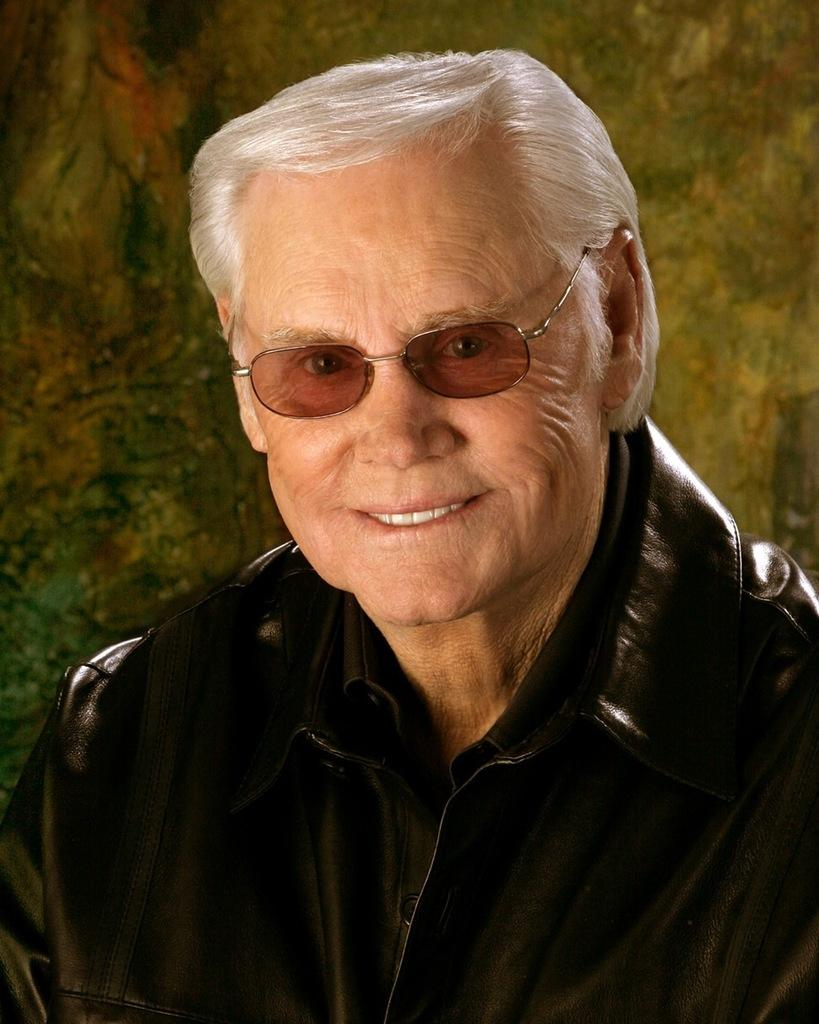Who is present in the image? There is a man in the image. What is the man doing in the image? The man is smiling in the image. What is the man wearing in the image? The man is wearing a black jacket in the image. What type of plastic can be seen blowing in the wind in the image? There is no plastic visible in the image, nor is there any wind blowing anything. 